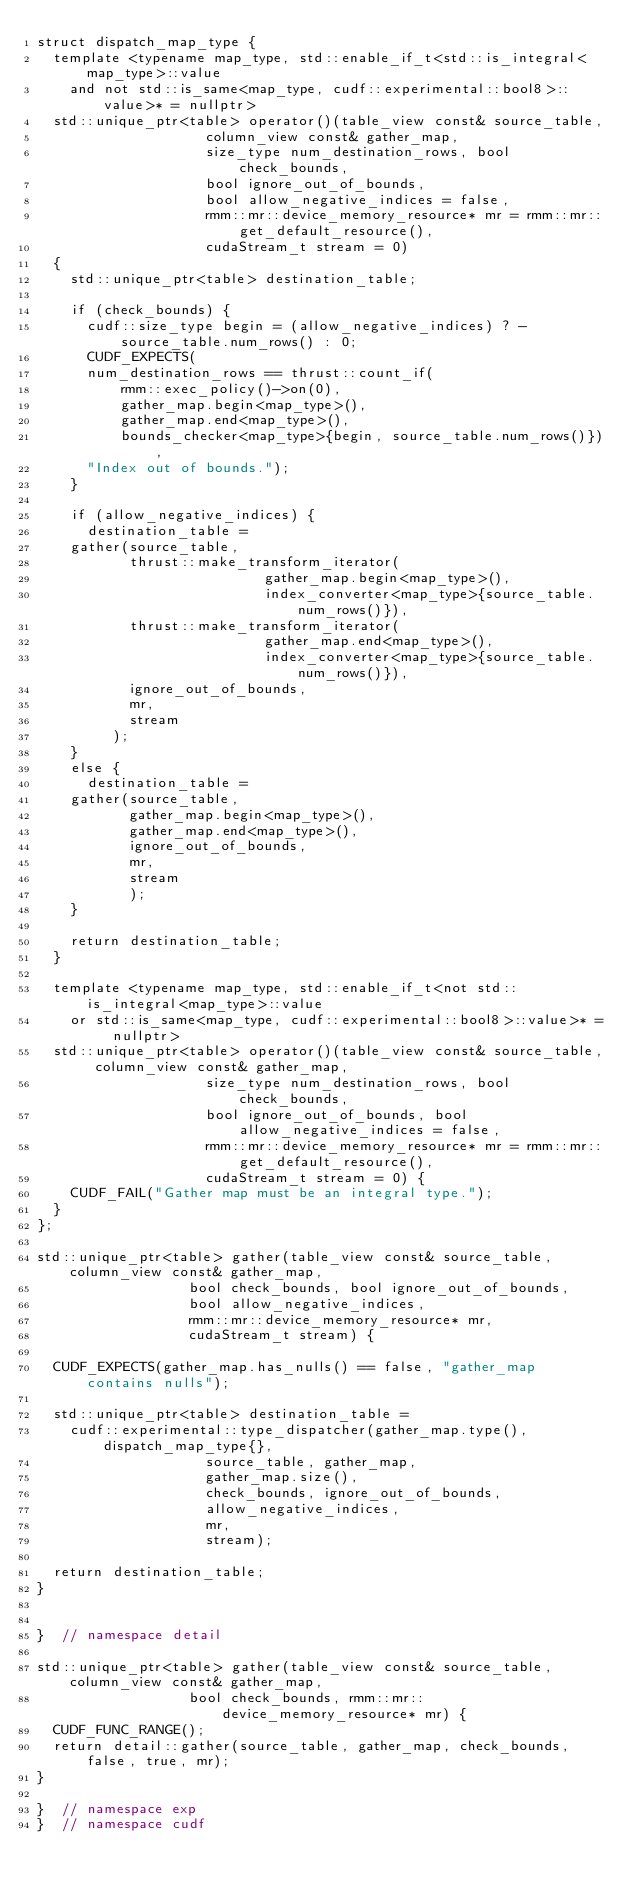<code> <loc_0><loc_0><loc_500><loc_500><_Cuda_>struct dispatch_map_type {
  template <typename map_type, std::enable_if_t<std::is_integral<map_type>::value
    and not std::is_same<map_type, cudf::experimental::bool8>::value>* = nullptr>
  std::unique_ptr<table> operator()(table_view const& source_table,
				    column_view const& gather_map,
				    size_type num_destination_rows, bool check_bounds,
				    bool ignore_out_of_bounds,
				    bool allow_negative_indices = false,
				    rmm::mr::device_memory_resource* mr = rmm::mr::get_default_resource(),
				    cudaStream_t stream = 0)
  {
    std::unique_ptr<table> destination_table;

    if (check_bounds) {
      cudf::size_type begin = (allow_negative_indices) ? -source_table.num_rows() : 0;
      CUDF_EXPECTS(
	  num_destination_rows == thrust::count_if(
	      rmm::exec_policy()->on(0),
	      gather_map.begin<map_type>(),
	      gather_map.end<map_type>(),
	      bounds_checker<map_type>{begin, source_table.num_rows()}),
	  "Index out of bounds.");
    }

    if (allow_negative_indices) {
      destination_table =
	gather(source_table,
	       thrust::make_transform_iterator(
					       gather_map.begin<map_type>(),
					       index_converter<map_type>{source_table.num_rows()}),
	       thrust::make_transform_iterator(
					       gather_map.end<map_type>(),
					       index_converter<map_type>{source_table.num_rows()}),
	       ignore_out_of_bounds,
	       mr,
	       stream
	     );
    }
    else {
      destination_table =
	gather(source_table,
	       gather_map.begin<map_type>(),
	       gather_map.end<map_type>(),
	       ignore_out_of_bounds,
	       mr,
	       stream
	       );
    }

    return destination_table;
  }

  template <typename map_type, std::enable_if_t<not std::is_integral<map_type>::value
    or std::is_same<map_type, cudf::experimental::bool8>::value>* = nullptr>
  std::unique_ptr<table> operator()(table_view const& source_table, column_view const& gather_map,
				    size_type num_destination_rows, bool check_bounds,
				    bool ignore_out_of_bounds, bool allow_negative_indices = false,
				    rmm::mr::device_memory_resource* mr = rmm::mr::get_default_resource(),
				    cudaStream_t stream = 0) {
    CUDF_FAIL("Gather map must be an integral type.");
  }
};

std::unique_ptr<table> gather(table_view const& source_table, column_view const& gather_map,
			      bool check_bounds, bool ignore_out_of_bounds,
			      bool allow_negative_indices,
			      rmm::mr::device_memory_resource* mr,
			      cudaStream_t stream) {

  CUDF_EXPECTS(gather_map.has_nulls() == false, "gather_map contains nulls");

  std::unique_ptr<table> destination_table =
    cudf::experimental::type_dispatcher(gather_map.type(), dispatch_map_type{},
					source_table, gather_map,
					gather_map.size(),
					check_bounds, ignore_out_of_bounds,
					allow_negative_indices,
					mr,
					stream);

  return destination_table;
}


}  // namespace detail

std::unique_ptr<table> gather(table_view const& source_table, column_view const& gather_map,
			      bool check_bounds, rmm::mr::device_memory_resource* mr) {
  CUDF_FUNC_RANGE();
  return detail::gather(source_table, gather_map, check_bounds, false, true, mr);
}

}  // namespace exp
}  // namespace cudf
</code> 